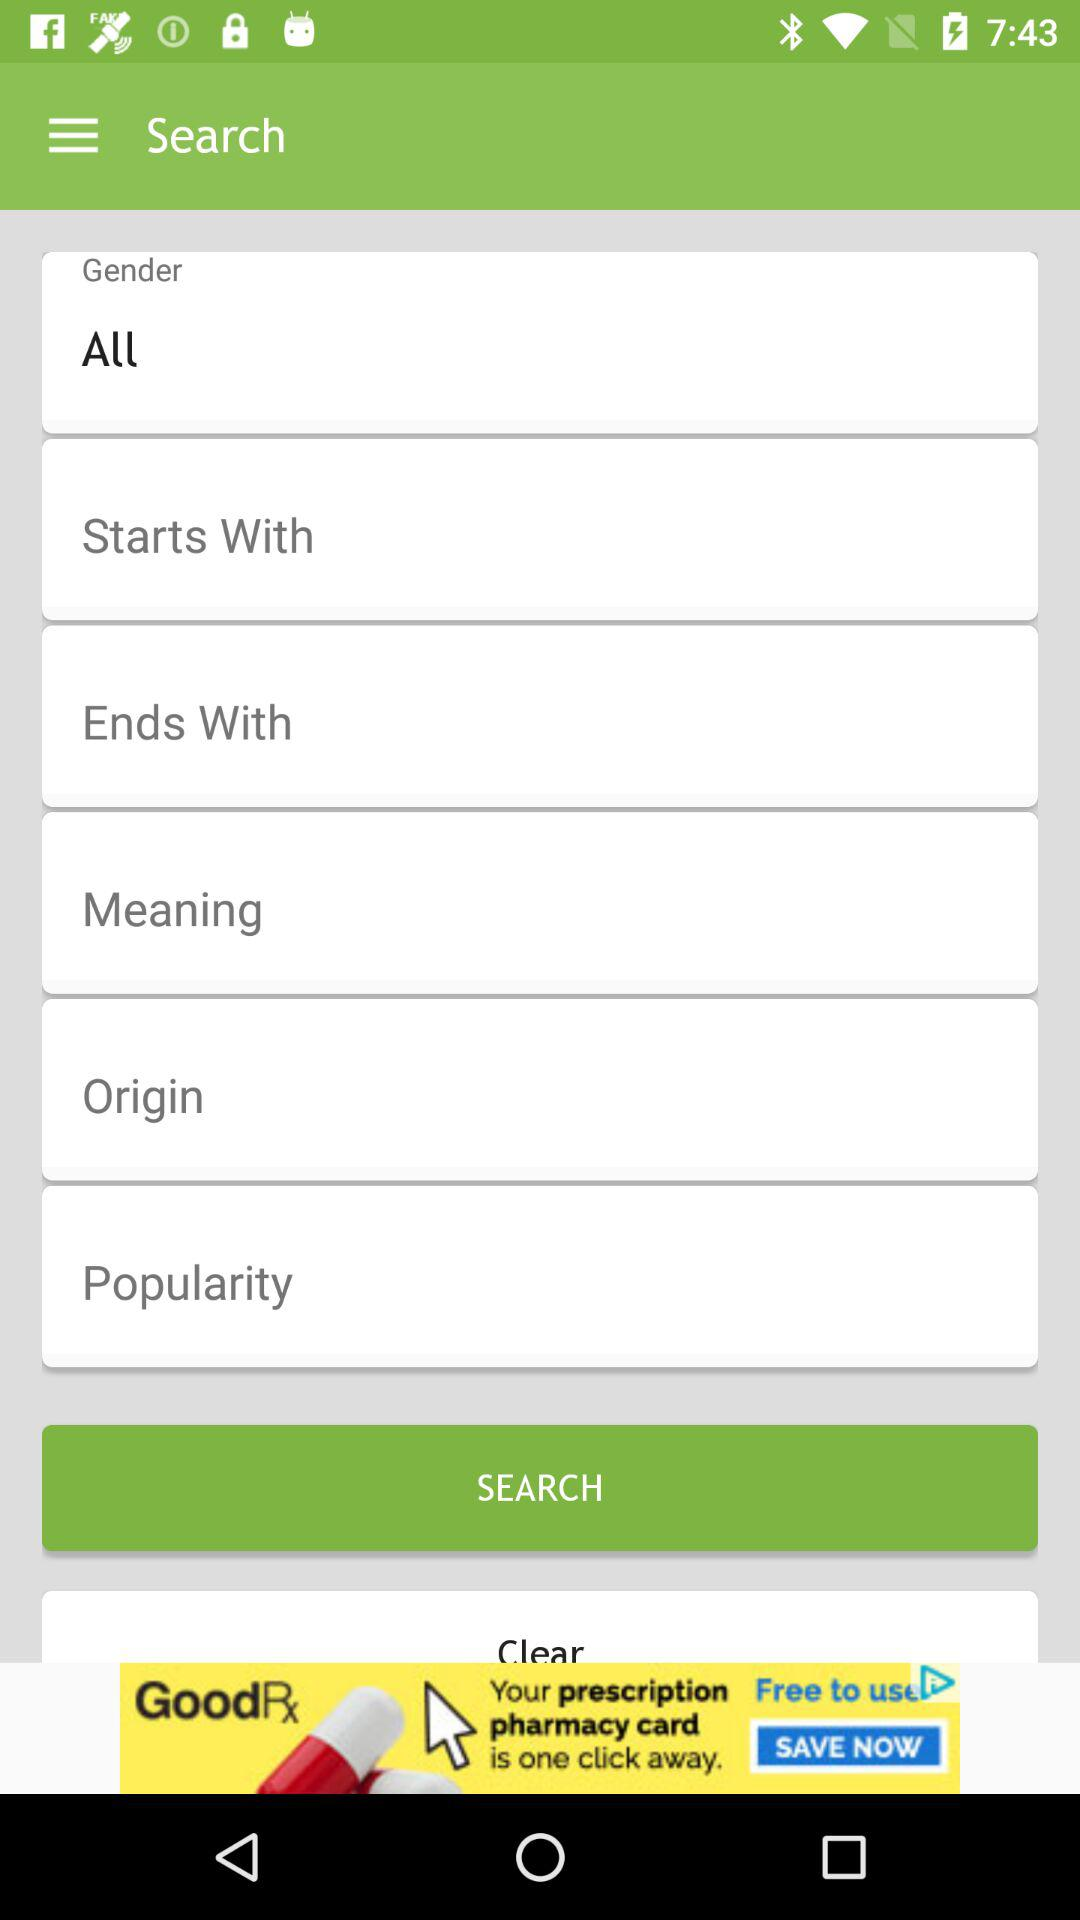What is selected in the "Gender" option? The selected option is "All". 